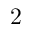<formula> <loc_0><loc_0><loc_500><loc_500>2</formula> 